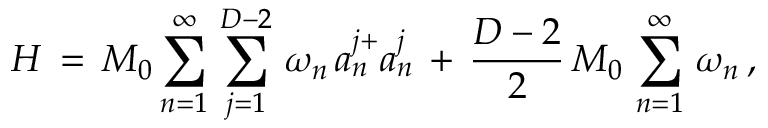<formula> <loc_0><loc_0><loc_500><loc_500>H \, = \, M _ { 0 } \sum _ { n = 1 } ^ { \infty } \, \sum _ { j = 1 } ^ { D - 2 } \, \omega _ { n } \, a _ { n } ^ { j + } a _ { n } ^ { j } \, + \, \frac { D - 2 } { 2 } \, M _ { 0 } \, \sum _ { n = 1 } ^ { \infty } \, \omega _ { n } \, { , }</formula> 